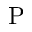Convert formula to latex. <formula><loc_0><loc_0><loc_500><loc_500>P</formula> 